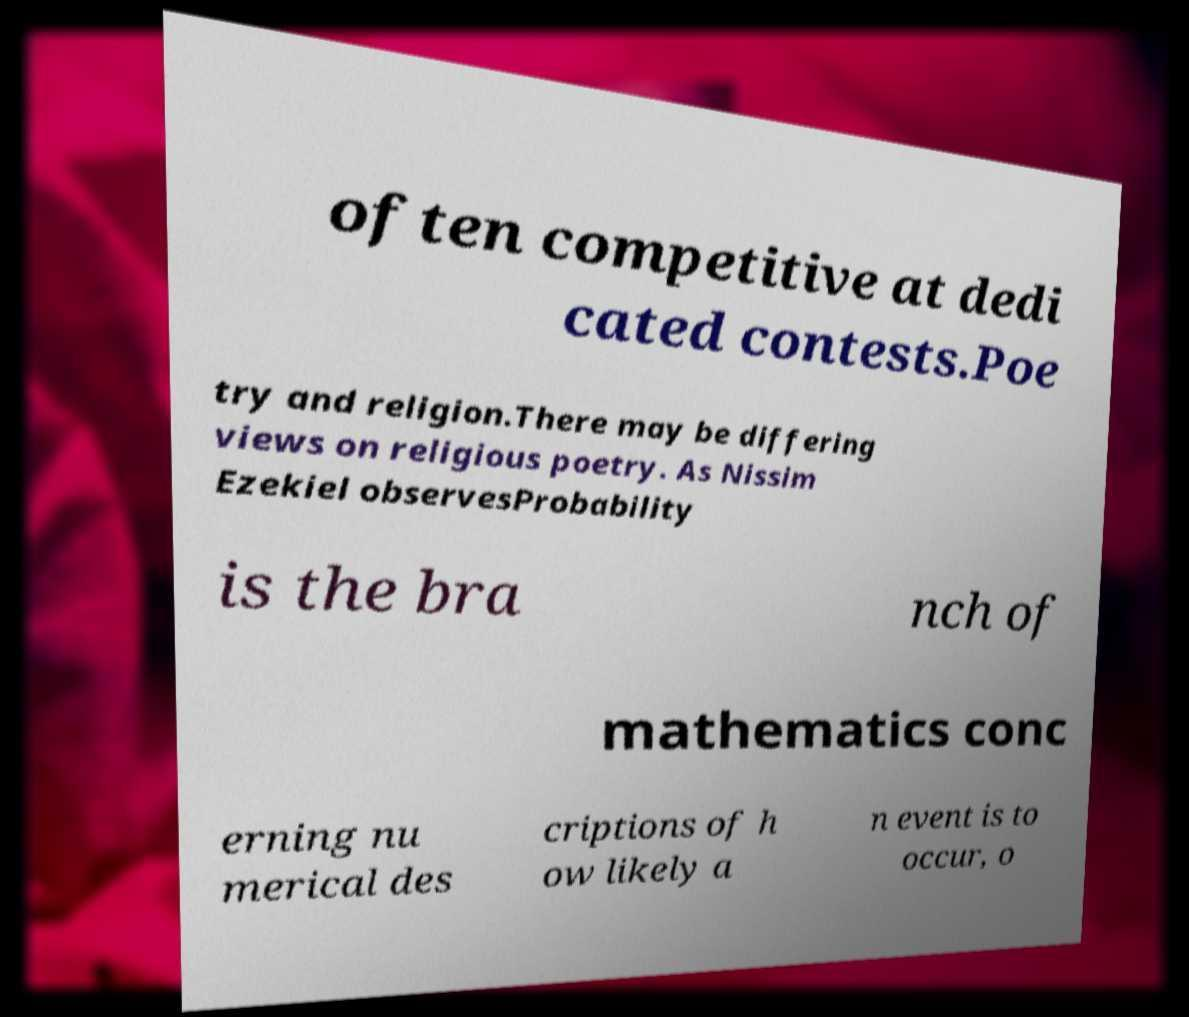Can you accurately transcribe the text from the provided image for me? often competitive at dedi cated contests.Poe try and religion.There may be differing views on religious poetry. As Nissim Ezekiel observesProbability is the bra nch of mathematics conc erning nu merical des criptions of h ow likely a n event is to occur, o 